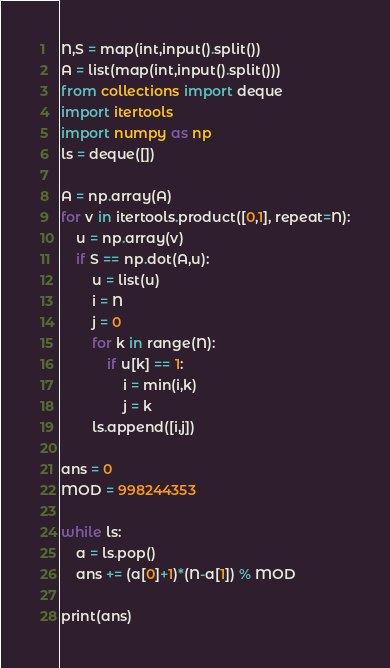Convert code to text. <code><loc_0><loc_0><loc_500><loc_500><_Python_>N,S = map(int,input().split())
A = list(map(int,input().split()))
from collections import deque
import itertools
import numpy as np
ls = deque([])

A = np.array(A)
for v in itertools.product([0,1], repeat=N):
    u = np.array(v)
    if S == np.dot(A,u):
        u = list(u)
        i = N
        j = 0
        for k in range(N):
            if u[k] == 1:
                i = min(i,k)
                j = k
        ls.append([i,j])

ans = 0
MOD = 998244353

while ls:
    a = ls.pop()
    ans += (a[0]+1)*(N-a[1]) % MOD

print(ans)
</code> 